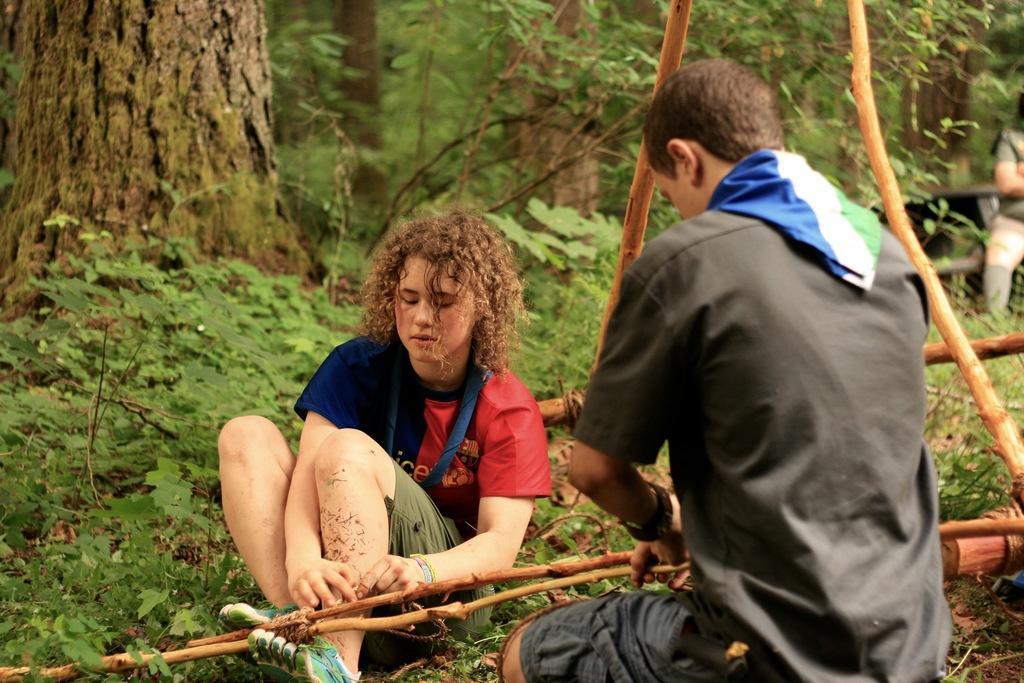Describe this image in one or two sentences. In this picture we can see people on the ground, here we can see sticks and in the background we can see trees. 